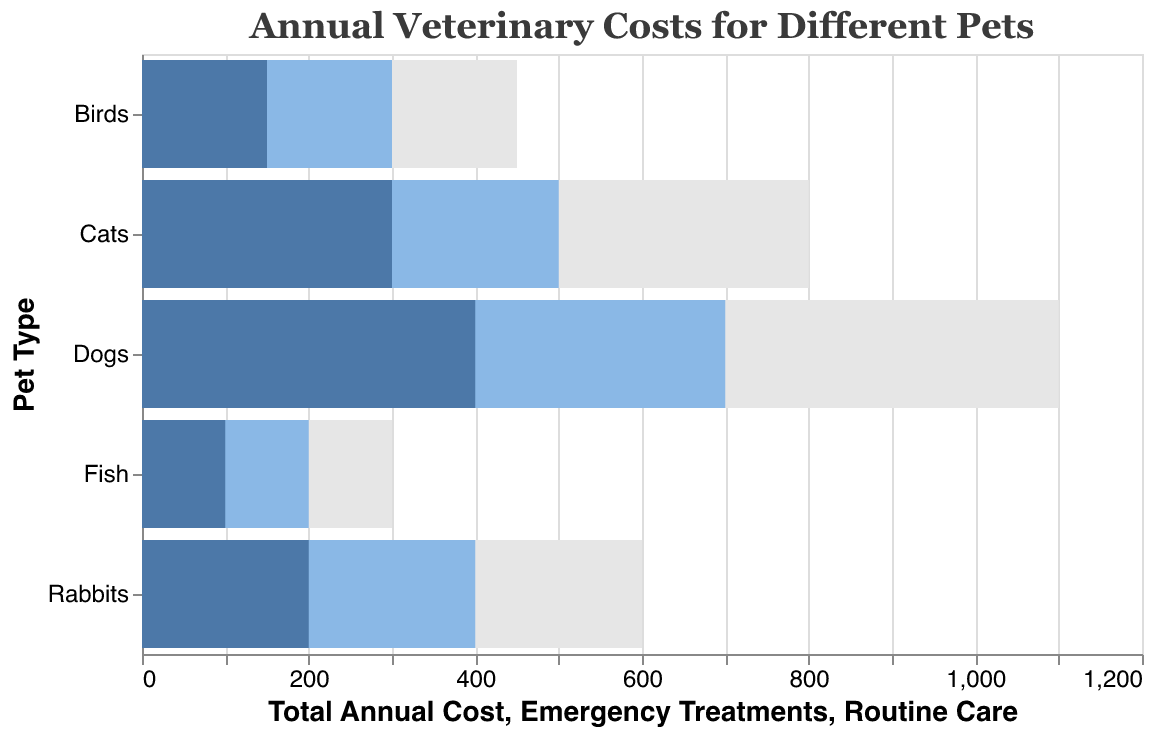Which pet type has the highest total annual veterinary cost? To answer this, we look for the longest bar representing the "Total Annual Cost". The 'Dogs' bar extends the farthest, indicating they have the highest cost.
Answer: Dogs Which pet type incurs the lowest total annual veterinary cost? We need to find the shortest bar representing the "Total Annual Cost". The 'Fish' bar is the shortest, meaning they have the lowest cost.
Answer: Fish What is the combined cost of routine care and emergency treatments for Cats? Add the costs for routine care (300) and emergency treatments (500) for Cats. The combined cost is 300 + 500 = 800.
Answer: $800 How much more do emergency treatments cost for Dogs compared to Cats? To determine the difference, subtract Cats' emergency treatments cost (500) from Dogs' (700). The difference is 700 - 500 = 200.
Answer: $200 If you have a budget of $1000 for vet costs, which pet types fit within this budget? Compare each pet's total annual cost to the $1000 budget. Dogs cost $1100, thus exceeding the budget. The other pets (Cats, Rabbits, Birds, Fish) have costs of $800, $600, $450, and $300 respectively, all within the budget.
Answer: Cats, Rabbits, Birds, Fish What proportion of the total annual cost for Birds is spent on emergency treatments? Divide Birds' emergency treatment cost (300) by their total annual cost (450) and multiply by 100 for percentage: (300/450) * 100 ≈ 67%.
Answer: 67% Which pet type's routine care cost is closest to the routine care cost of Fish? Compare the routine care costs: Fish ($100), Birds ($150), Rabbits ($200), Cats ($300), Dogs ($400). Birds, with $150, is closest to Fish's $100.
Answer: Birds What is the average total annual veterinary cost for all pet types? Sum all the total annual costs (800 + 1100 + 600 + 450 + 300 = 3250) and divide by the number of pet types (5). The average is 3250 / 5 = 650.
Answer: $650 How do the emergency treatment costs of Cats and Rabbits compare? Comparing the bars, both Cats and Rabbits have emergency treatment costs of $500 and $400 respectively. Cats' expenses ($500) are higher than Rabbits' ($400).
Answer: Cats > Rabbits Among the pet types shown, which one shows the least difference between routine care and emergency treatments? Calculate the differences: Cats (200), Dogs (300), Rabbits (200), Birds (150), Fish (100). Fish has the smallest difference of 100.
Answer: Fish 